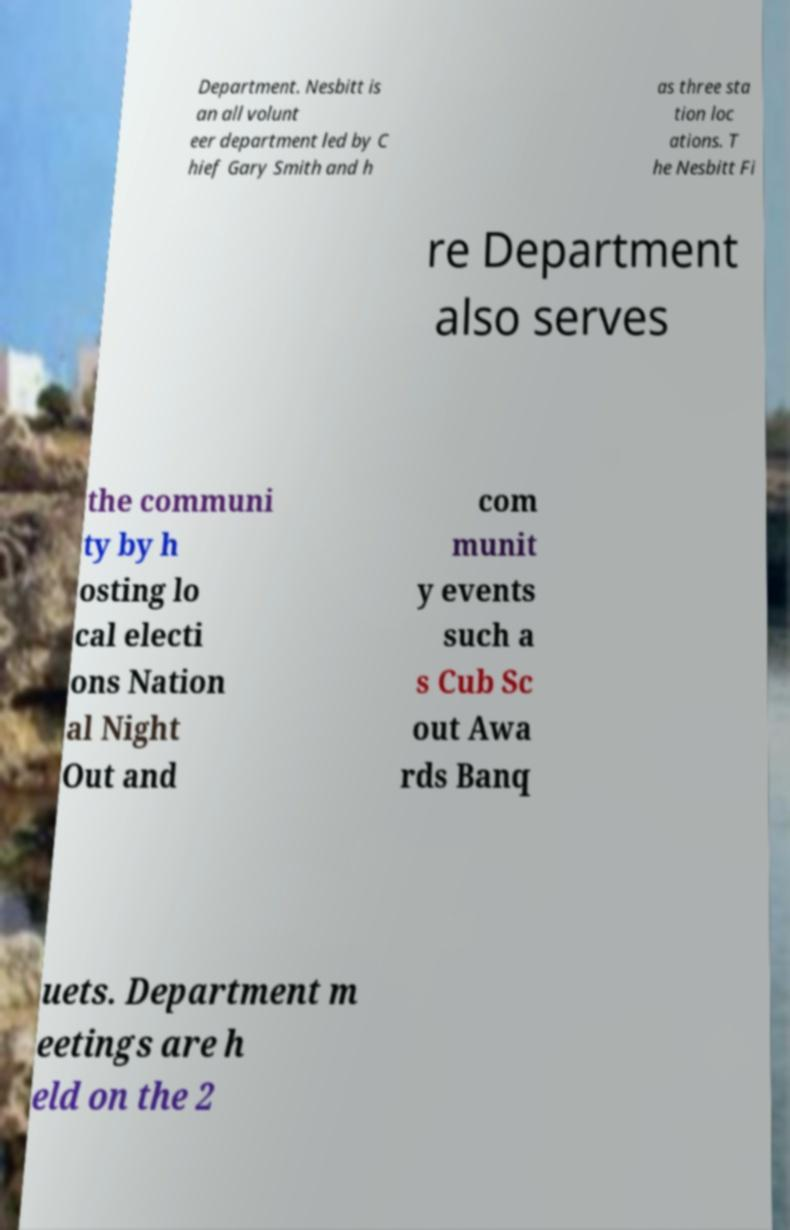What messages or text are displayed in this image? I need them in a readable, typed format. Department. Nesbitt is an all volunt eer department led by C hief Gary Smith and h as three sta tion loc ations. T he Nesbitt Fi re Department also serves the communi ty by h osting lo cal electi ons Nation al Night Out and com munit y events such a s Cub Sc out Awa rds Banq uets. Department m eetings are h eld on the 2 